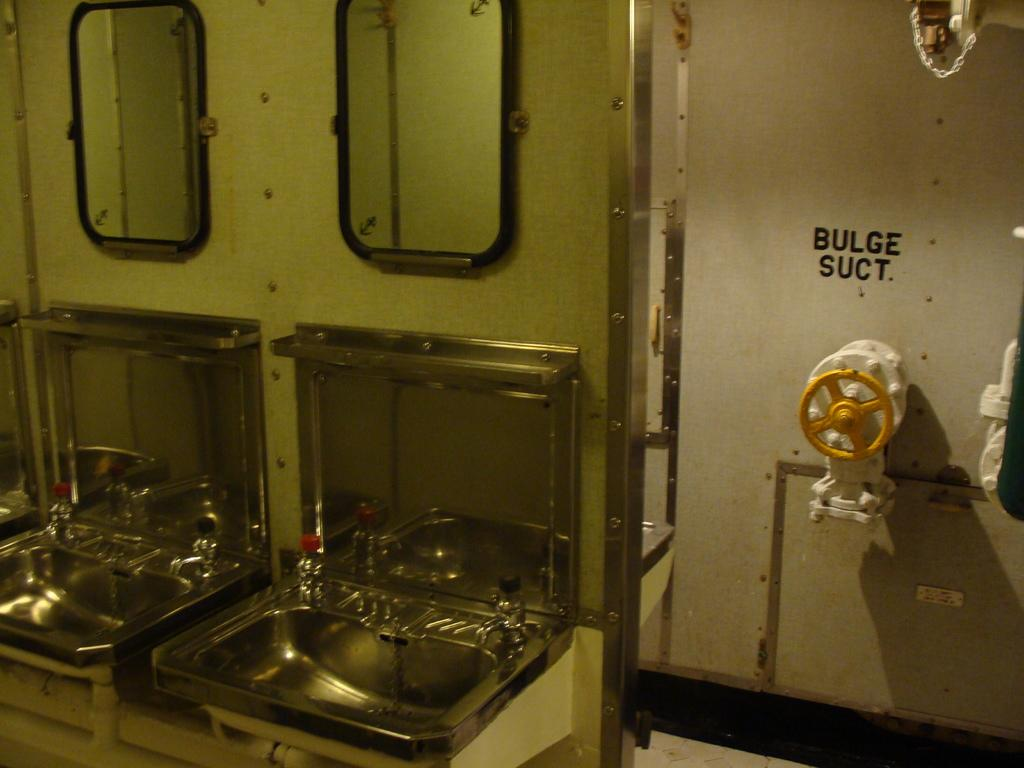<image>
Render a clear and concise summary of the photo. A room with 2 sinks and a wall showing Bulge suct at the back. 